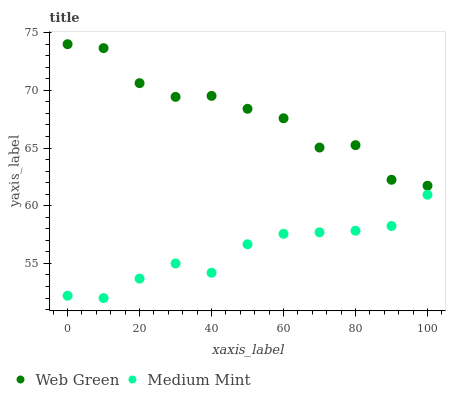Does Medium Mint have the minimum area under the curve?
Answer yes or no. Yes. Does Web Green have the maximum area under the curve?
Answer yes or no. Yes. Does Web Green have the minimum area under the curve?
Answer yes or no. No. Is Medium Mint the smoothest?
Answer yes or no. Yes. Is Web Green the roughest?
Answer yes or no. Yes. Is Web Green the smoothest?
Answer yes or no. No. Does Medium Mint have the lowest value?
Answer yes or no. Yes. Does Web Green have the lowest value?
Answer yes or no. No. Does Web Green have the highest value?
Answer yes or no. Yes. Is Medium Mint less than Web Green?
Answer yes or no. Yes. Is Web Green greater than Medium Mint?
Answer yes or no. Yes. Does Medium Mint intersect Web Green?
Answer yes or no. No. 